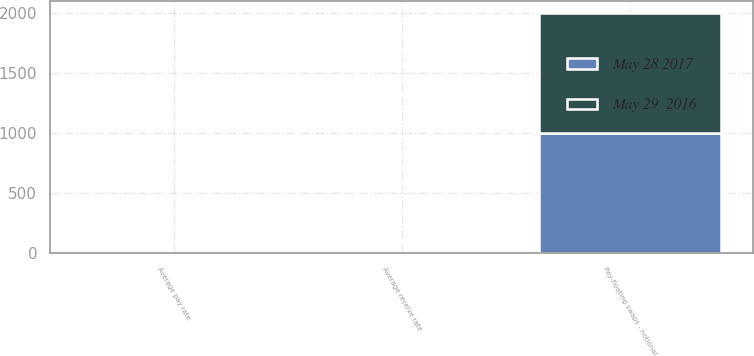<chart> <loc_0><loc_0><loc_500><loc_500><stacked_bar_chart><ecel><fcel>Pay-floating swaps - notional<fcel>Average receive rate<fcel>Average pay rate<nl><fcel>May 28 2017<fcel>1000<fcel>1.8<fcel>1.6<nl><fcel>May 29  2016<fcel>1000<fcel>1.8<fcel>1.1<nl></chart> 